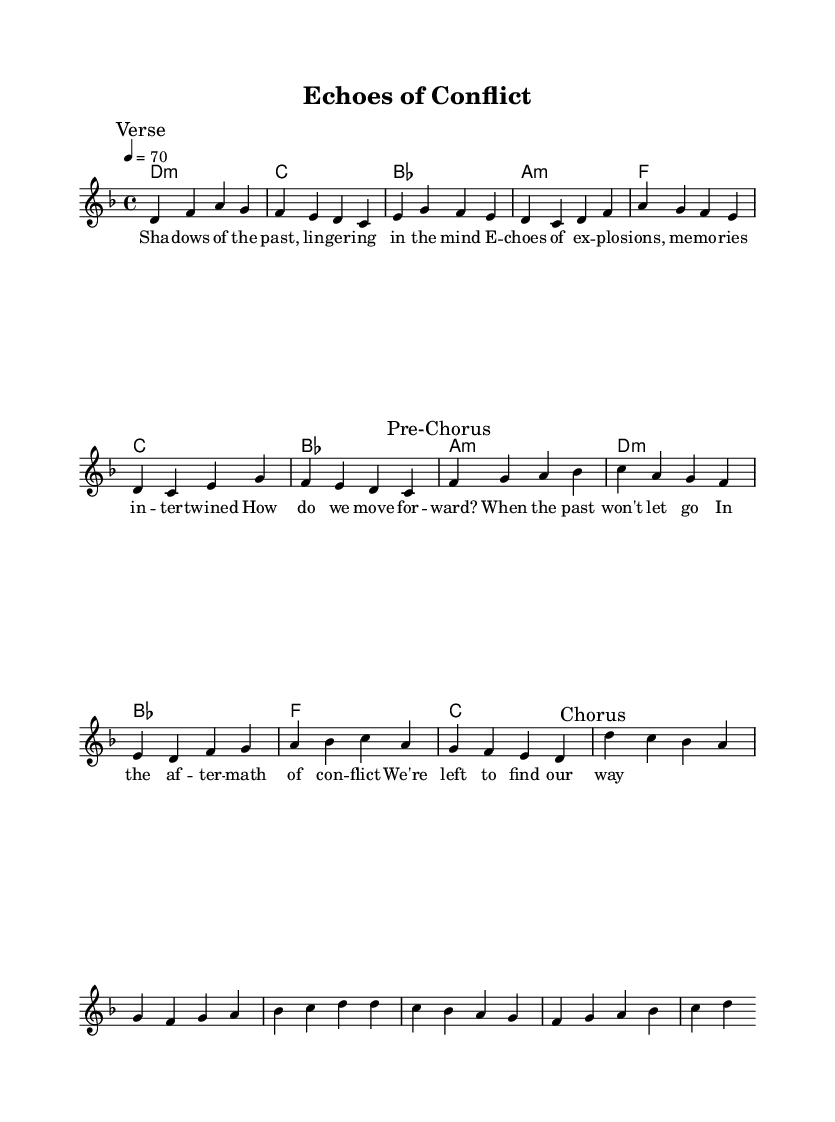What is the key signature of this music? The key signature shows two flats (B♭ and E♭) at the beginning of the staff, which indicates that the piece is in D minor.
Answer: D minor What is the time signature of this music? The time signature is indicated at the beginning of the staff, showing a "4/4" which means there are four beats in a measure.
Answer: 4/4 What is the tempo marking in this music? The tempo is indicated as "4 = 70," meaning each quarter note should be played at a speed of 70 beats per minute.
Answer: 70 How many measures are in the verse section? By counting the number of complete musical phrases marked as "Verse," which contain four bars each, there are a total of 8 measures.
Answer: 8 Which section follows the verse? The notation indicates a section marked "Pre-Chorus" right after the "Verse" section, indicating the song structure.
Answer: Pre-Chorus What is the first harmony chord? The first chord listed in the chord progression is D minor, as denoted at the start of the harmonies section.
Answer: D minor What lyrical theme is presented in the verses? The verse lyrics reflect on memories of conflict and the difficulty in moving forward, capturing the psychological impact of war.
Answer: Memories of conflict 